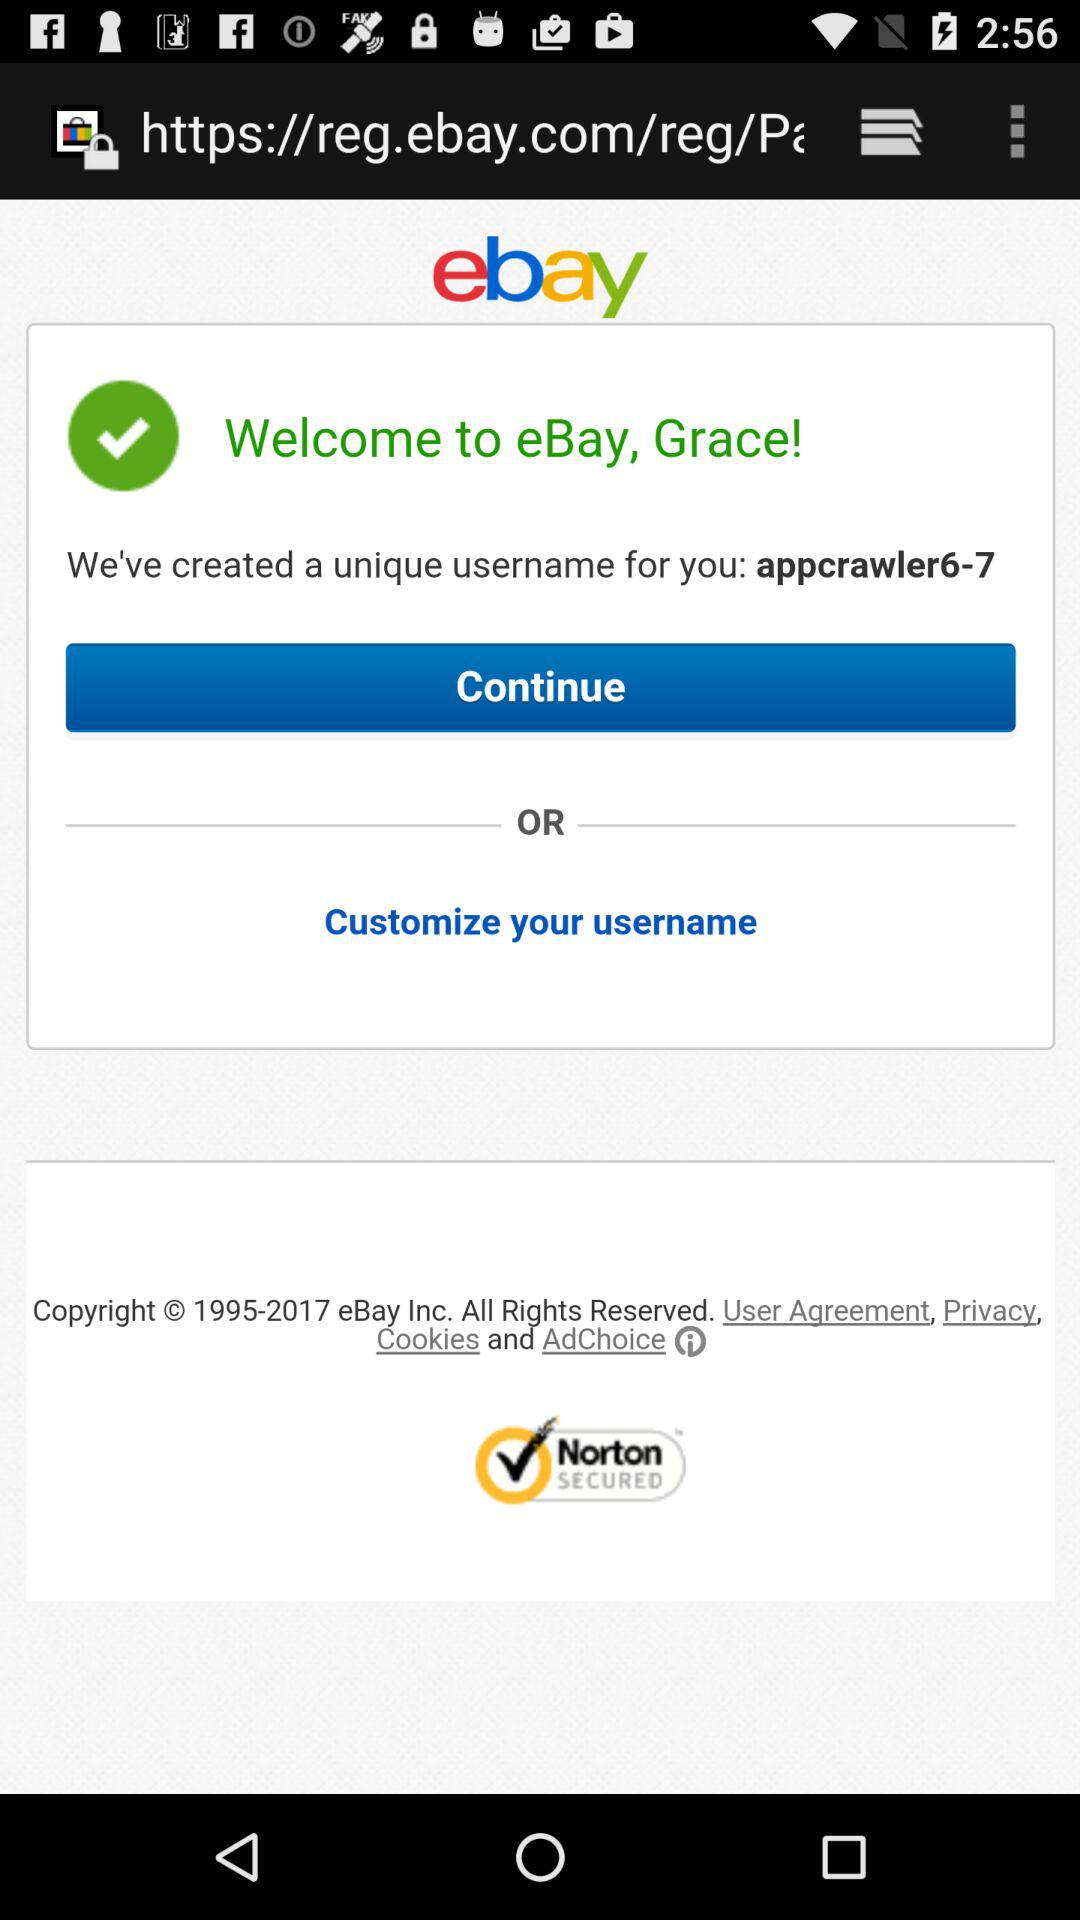What is the application name? The application name is "ebay". 